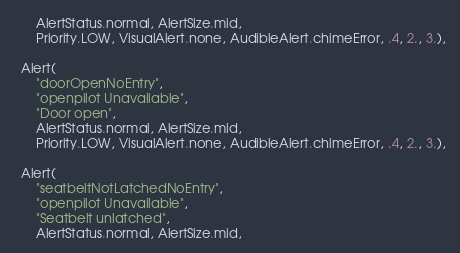Convert code to text. <code><loc_0><loc_0><loc_500><loc_500><_Python_>      AlertStatus.normal, AlertSize.mid,
      Priority.LOW, VisualAlert.none, AudibleAlert.chimeError, .4, 2., 3.),

  Alert(
      "doorOpenNoEntry",
      "openpilot Unavailable",
      "Door open",
      AlertStatus.normal, AlertSize.mid,
      Priority.LOW, VisualAlert.none, AudibleAlert.chimeError, .4, 2., 3.),

  Alert(
      "seatbeltNotLatchedNoEntry",
      "openpilot Unavailable",
      "Seatbelt unlatched",
      AlertStatus.normal, AlertSize.mid,</code> 